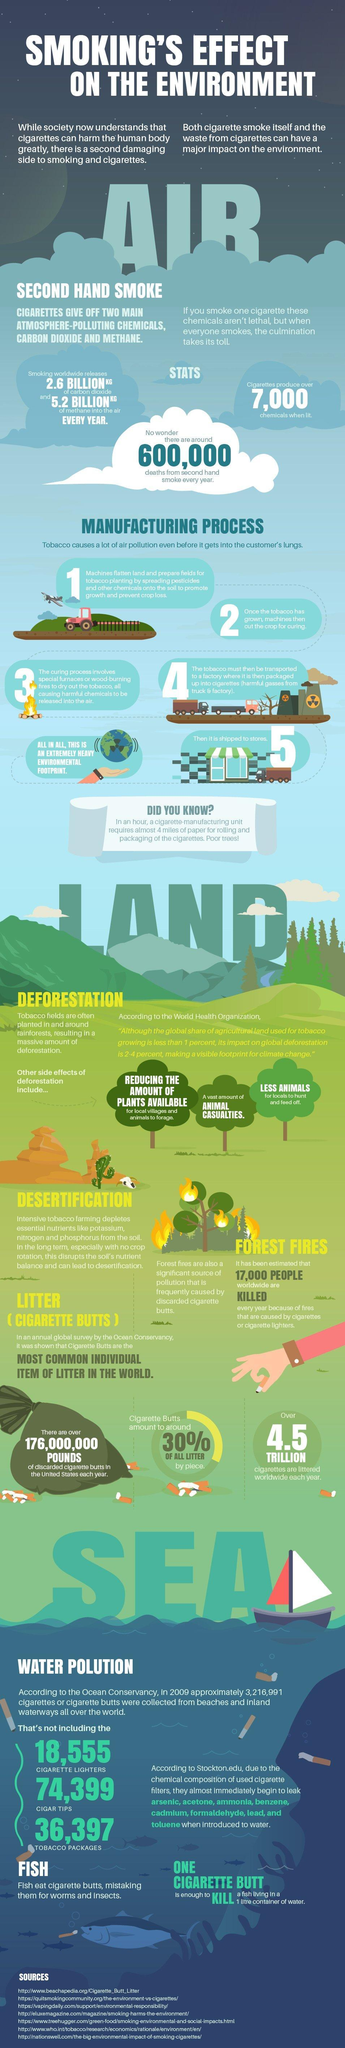How many sources are listed at the bottom?
Answer the question with a short phrase. 7 